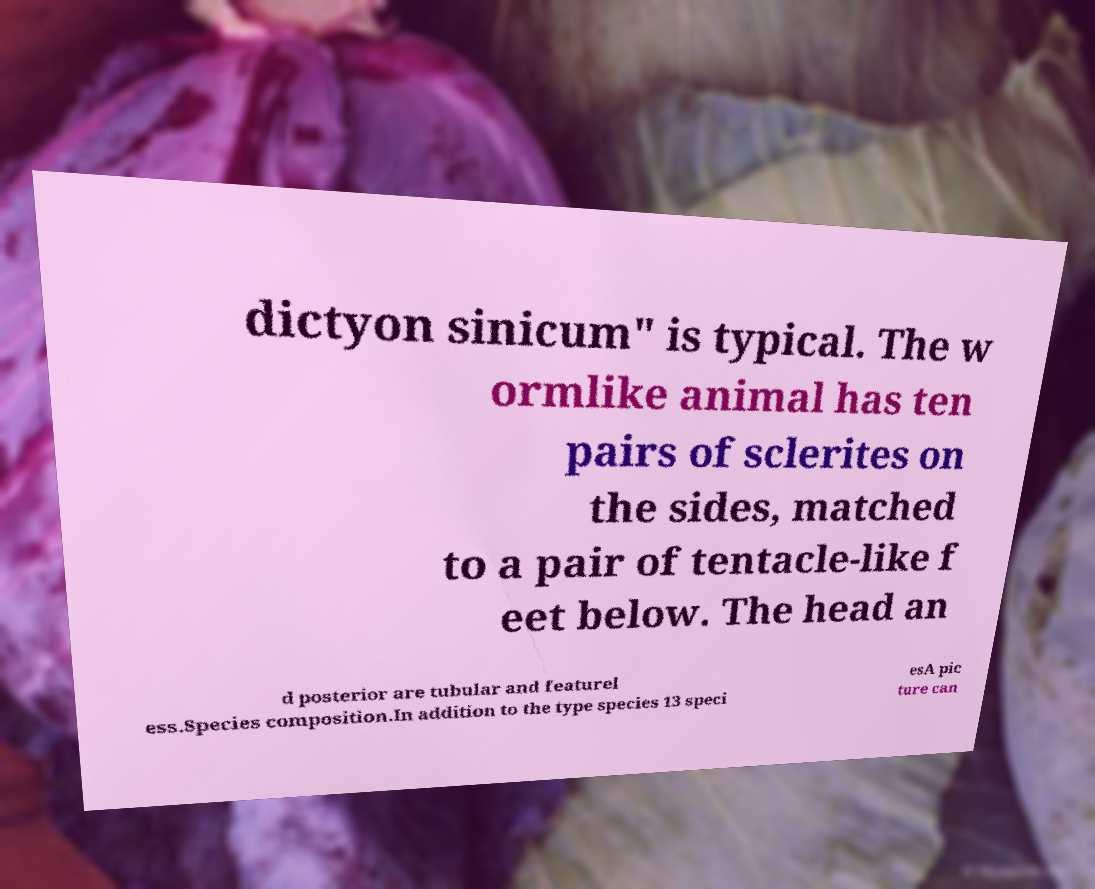I need the written content from this picture converted into text. Can you do that? dictyon sinicum" is typical. The w ormlike animal has ten pairs of sclerites on the sides, matched to a pair of tentacle-like f eet below. The head an d posterior are tubular and featurel ess.Species composition.In addition to the type species 13 speci esA pic ture can 